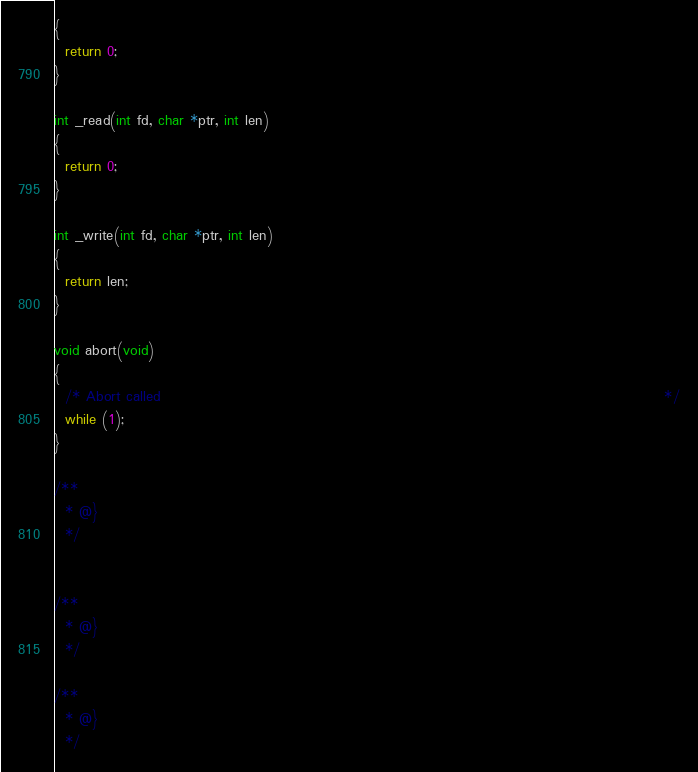<code> <loc_0><loc_0><loc_500><loc_500><_C_>{
  return 0;
}

int _read(int fd, char *ptr, int len)
{
  return 0;
}

int _write(int fd, char *ptr, int len)
{
  return len;
}

void abort(void)
{
  /* Abort called                                                                                           */
  while (1);
}

/**
  * @}
  */


/**
  * @}
  */

/**
  * @}
  */
</code> 